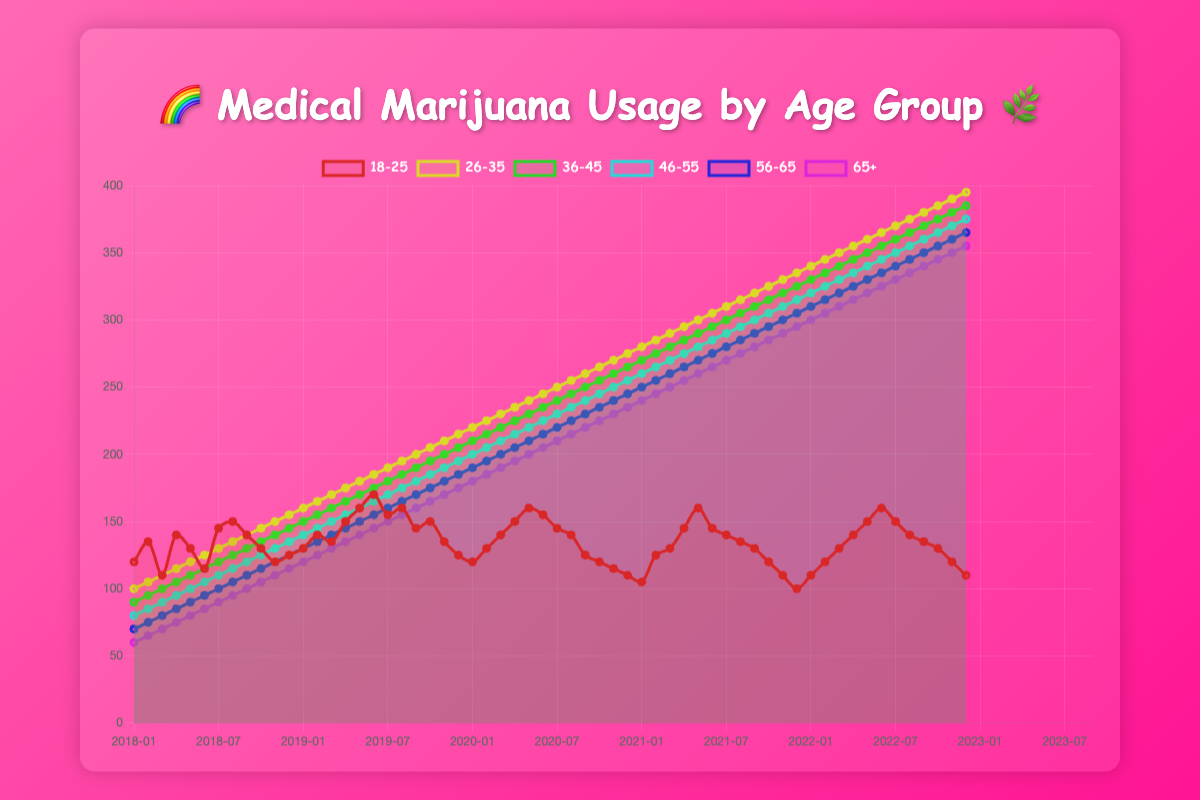Which age group has the highest usage of medical marijuana in 2023-01? From the figure, observe the y-axis values for January 2023 across all age groups. The age group "26-35" has the highest usage at 395 units.
Answer: 26-35 How did the usage trend for the age group 18-25 change between January 2020 and January 2021? Locate the points corresponding to January 2020 and January 2021 for the age group 18-25, then note the change in the trend. The value decreased from approximately 130 to 120 units.
Answer: Decreased What's the combined usage of the age group 46-55 from January to June 2020? Sum the usage values for the age group 46-55 from January to June 2020: 260 + 265 + 270 + 275 + 280 + 285 = 1635 units.
Answer: 1635 Which age group had the most stable or least fluctuating trend in the past 5 years? Examine the line graph for each age group and look for the one with the least variation. The age group "36-45" shows a steadily increasing trend with minimal fluctuations.
Answer: 36-45 What is the visual difference in the color representing the age groups 18-25 and 56-65? The line representing the age group 18-25 is distinctly colored differently from the line for 56-65. The 18-25 line is more vibrant, while the 56-65 line is calmer.
Answer: More vibrant Which months had a significant spike in usage for the age group 18-25? Identify the months in the figure where the line for the age group 18-25 has significant upward spikes. Specifically, April 2018, July 2018, and September 2019 show noticeable increases.
Answer: April 2018, July 2018, September 2019 Determine the average monthly usage for the age group 65+ over 2020. Sum the usage values for 65+ across all months in 2020 and divide by 12: (230 + 235 + 240 + 245 + 250 + 255 + 260 + 265 + 270 + 275 + 280 + 285) / 12 = 252.5.
Answer: 252.5 What is the trend observed for the age group 26-35 from 2018 to 2023? Observe the overall movement of the line representing 26-35 from the beginning to the end of the timeline. The trend shows a consistent and significant increase from 100 to 395 units.
Answer: Consistent and significant increase How does the peak value for the age group 56-65 compare to the peak value for 65+ in the last 5 years? Identify the highest points on the lines representing 56-65 and 65+. The peak for 56-65 is 365 units, while the peak for 65+ is 355 units. Thus, the peak for 56-65 is slightly higher.
Answer: Slightly higher Compare the overall trend for the age groups 18-25 and 46-55. Check the patterns of the lines for both age groups. The 18-25 age group exhibits more fluctuations and a downward trend overall, while 46-55 shows a steady upward trend.
Answer: 18-25: fluctuating, downward; 46-55: steady upward 